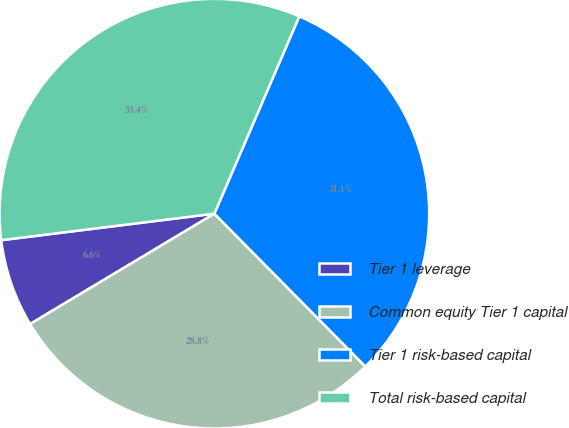Convert chart to OTSL. <chart><loc_0><loc_0><loc_500><loc_500><pie_chart><fcel>Tier 1 leverage<fcel>Common equity Tier 1 capital<fcel>Tier 1 risk-based capital<fcel>Total risk-based capital<nl><fcel>6.62%<fcel>28.82%<fcel>31.13%<fcel>33.44%<nl></chart> 